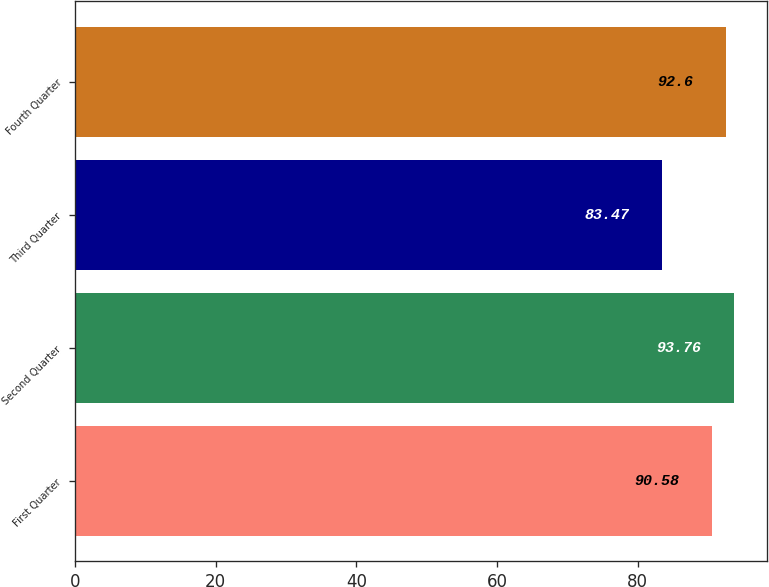Convert chart to OTSL. <chart><loc_0><loc_0><loc_500><loc_500><bar_chart><fcel>First Quarter<fcel>Second Quarter<fcel>Third Quarter<fcel>Fourth Quarter<nl><fcel>90.58<fcel>93.76<fcel>83.47<fcel>92.6<nl></chart> 